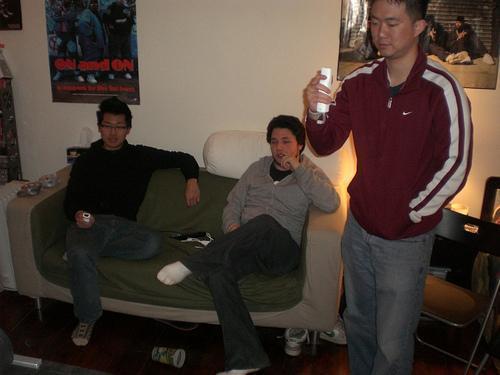How many people are in the photo?
Give a very brief answer. 3. How many people are on skateboards?
Give a very brief answer. 0. How many people are visible?
Give a very brief answer. 3. How many bird feeders are there?
Give a very brief answer. 0. 